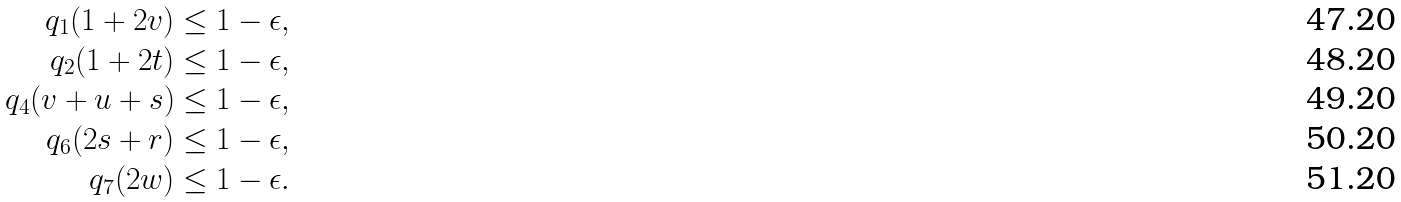<formula> <loc_0><loc_0><loc_500><loc_500>q _ { 1 } ( 1 + 2 v ) & \leq 1 - \epsilon , \\ q _ { 2 } ( 1 + 2 t ) & \leq 1 - \epsilon , \\ q _ { 4 } ( v + u + s ) & \leq 1 - \epsilon , \\ q _ { 6 } ( 2 s + r ) & \leq 1 - \epsilon , \\ q _ { 7 } ( 2 w ) & \leq 1 - \epsilon .</formula> 